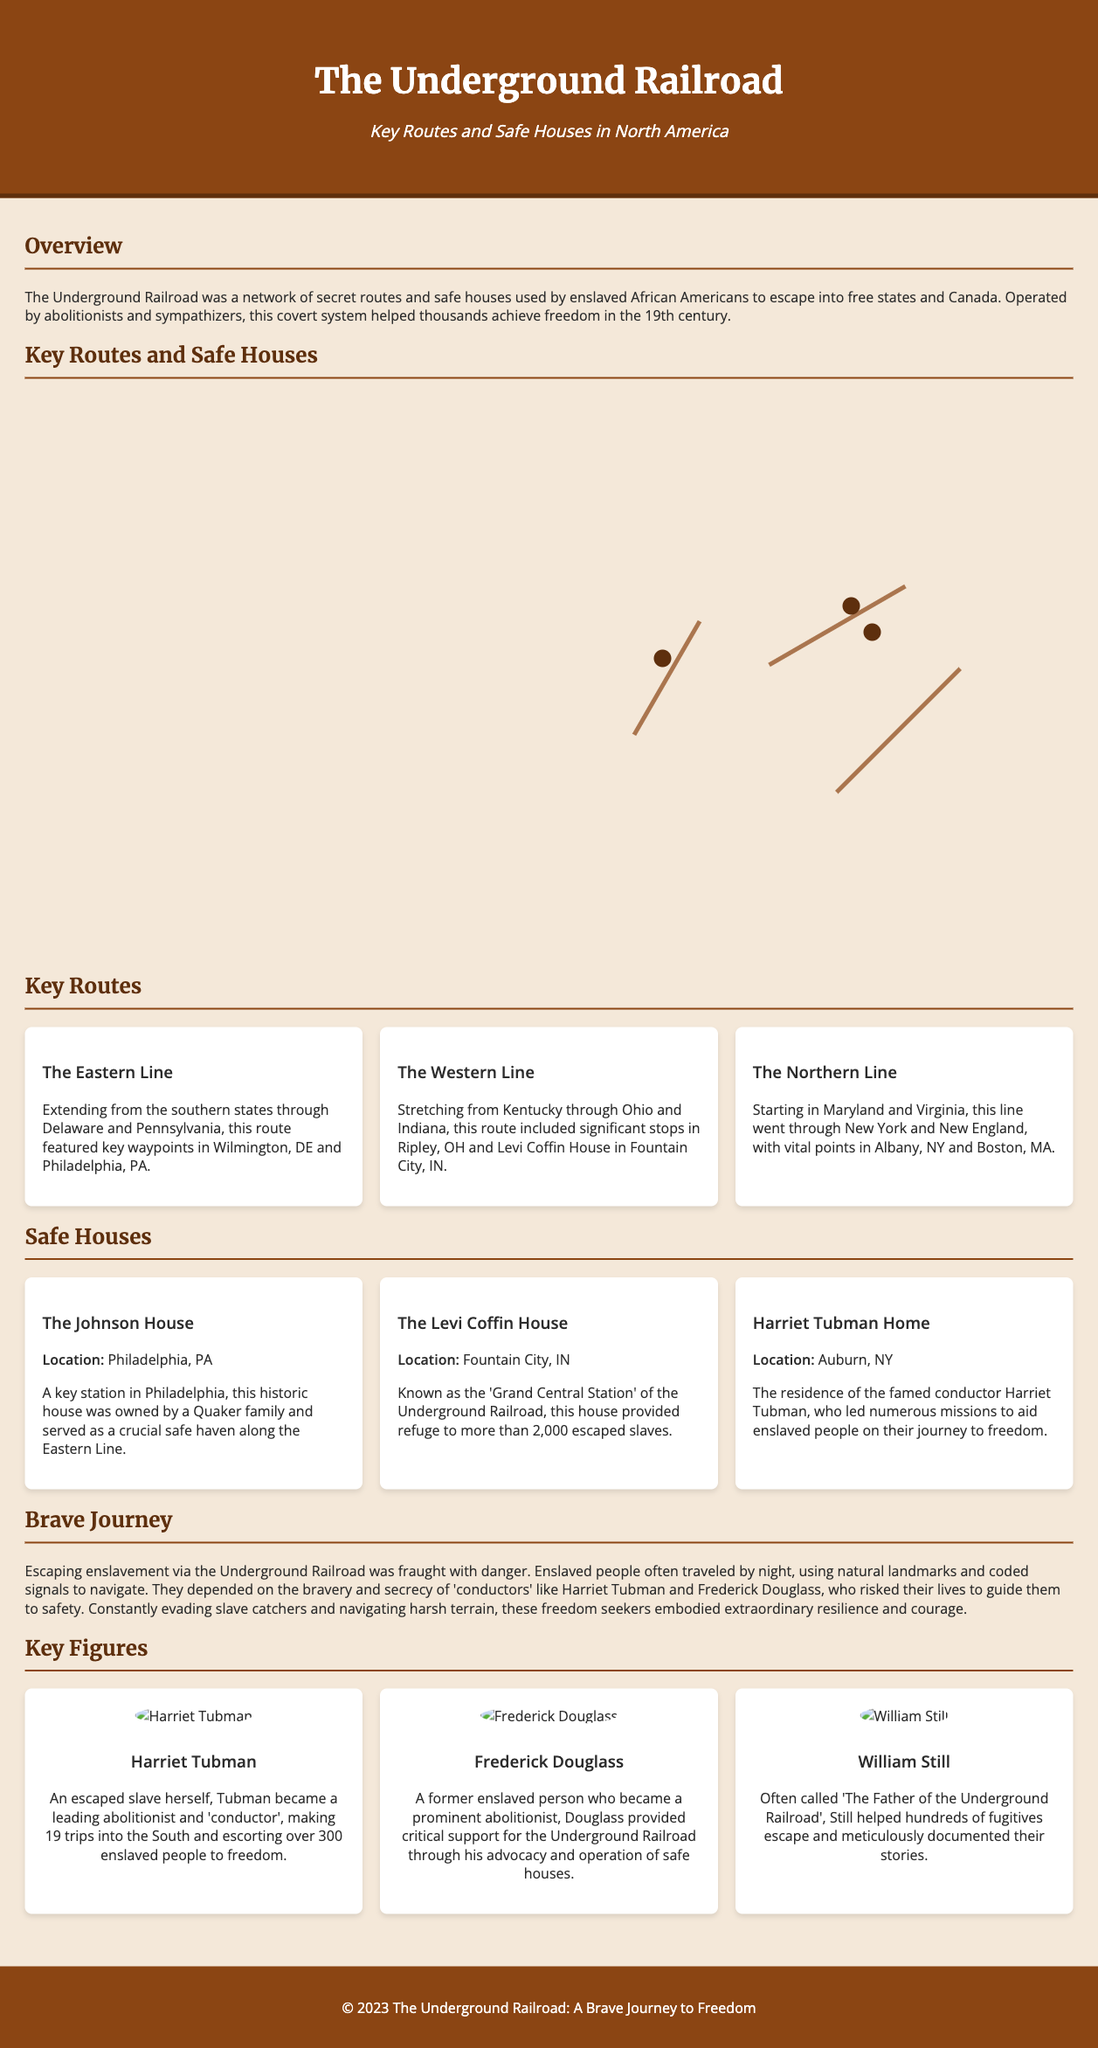What was the main purpose of the Underground Railroad? The document states that the Underground Railroad was a network used by enslaved African Americans to escape into free states and Canada.
Answer: Escape to freedom Where was the Levi Coffin House located? The document specifies that the Levi Coffin House is located in Fountain City, IN.
Answer: Fountain City, IN How many missions did Harriet Tubman undertake? According to the document, Harriet Tubman made 19 trips into the South to aid enslaved people.
Answer: 19 trips What notable figure helped document the stories of fugitives? The document refers to William Still as the person known for meticulously documenting the stories of fugitives.
Answer: William Still What is the significance of the Eastern Line? The Eastern Line is highlighted as extending from the southern states through Delaware and Pennsylvania, key for many fleeing enslaved people.
Answer: Key route What does the term "conductors" refer to in the context of the Underground Railroad? The document describes conductors as brave individuals, like Harriet Tubman, who guided enslaved people to safety.
Answer: Brave individuals What were the primary challenges faced by those escaping? The document mentions dangers such as evading slave catchers and navigating harsh terrain as primary challenges.
Answer: Evading slave catchers Which safe house is referred to as the "Grand Central Station"? The Levi Coffin House is referred to as the 'Grand Central Station' of the Underground Railroad in the document.
Answer: Levi Coffin House 